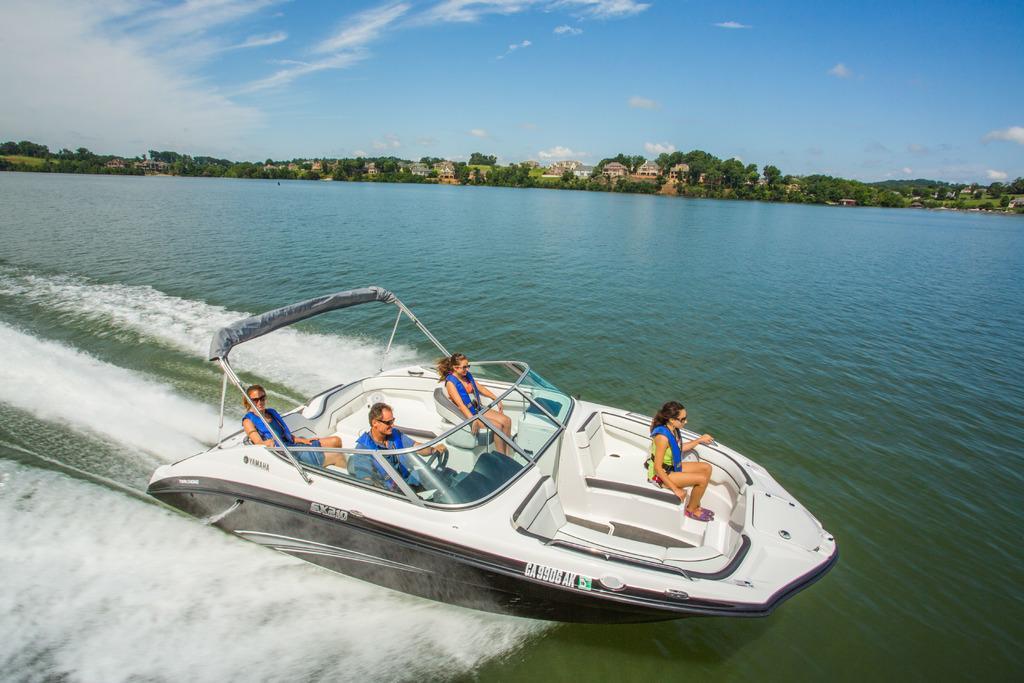Describe this image in one or two sentences. In this image we can see some people sitting in a boat placed in the water. In the center of the image we can see some buildings with windows, a group of trees. At the top of the image we can see the sky. 